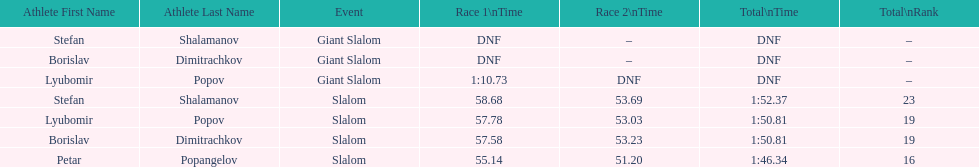Who was last in the slalom overall? Stefan Shalamanov. 